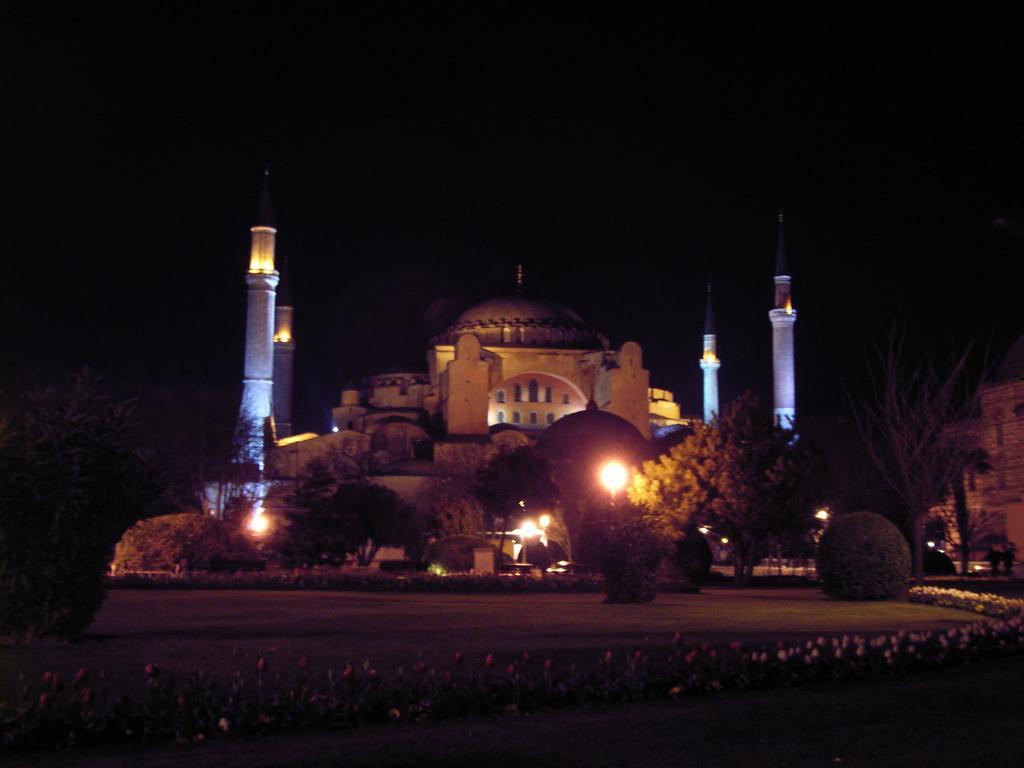Describe this image in one or two sentences. At the bottom of the image there are some plants and flowers. In the middle of the image there are some trees and poles and building. 